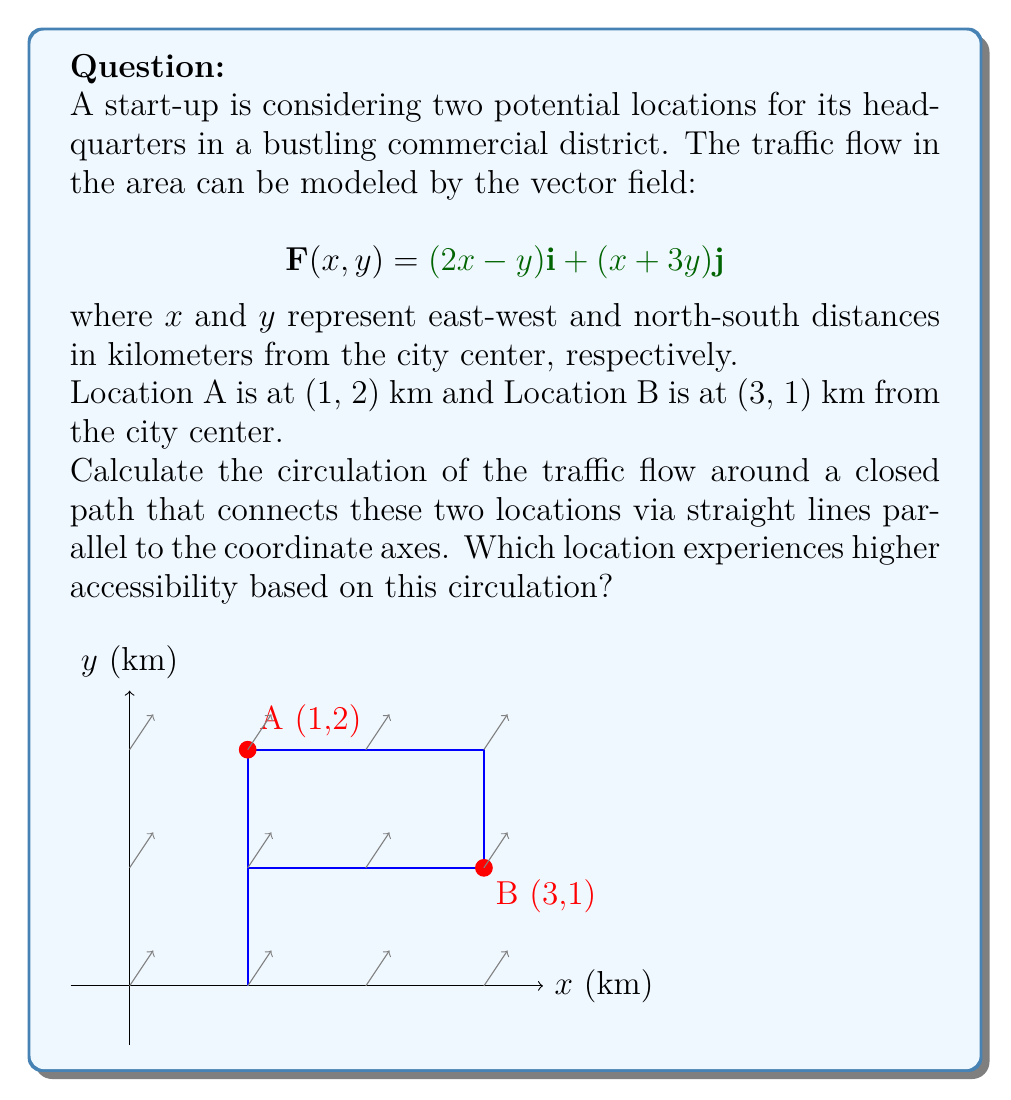Provide a solution to this math problem. To solve this problem, we'll use Green's theorem to calculate the circulation:

$$\oint_C \mathbf{F} \cdot d\mathbf{r} = \iint_R \left(\frac{\partial Q}{\partial x} - \frac{\partial P}{\partial y}\right) dA$$

where $P = 2x-y$ and $Q = x+3y$.

Step 1: Calculate $\frac{\partial Q}{\partial x}$ and $\frac{\partial P}{\partial y}$:
$$\frac{\partial Q}{\partial x} = 1$$
$$\frac{\partial P}{\partial y} = -1$$

Step 2: Compute $\frac{\partial Q}{\partial x} - \frac{\partial P}{\partial y}$:
$$\frac{\partial Q}{\partial x} - \frac{\partial P}{\partial y} = 1 - (-1) = 2$$

Step 3: Calculate the area of the rectangle formed by the path:
Area = $(3-1) \times (2-1) = 2$ sq km

Step 4: Apply Green's theorem:
$$\oint_C \mathbf{F} \cdot d\mathbf{r} = \iint_R 2 dA = 2 \times 2 = 4$$

The positive circulation indicates a counterclockwise flow, which generally improves accessibility.

Step 5: Analyze accessibility:
Location A (1,2) is closer to the center of the rectangular path and experiences more of the counterclockwise flow. Location B (3,1) is at the outer corner and experiences less of this beneficial circulation.

Therefore, Location A has higher accessibility based on this circulation analysis.
Answer: Location A (1,2) has higher accessibility. 